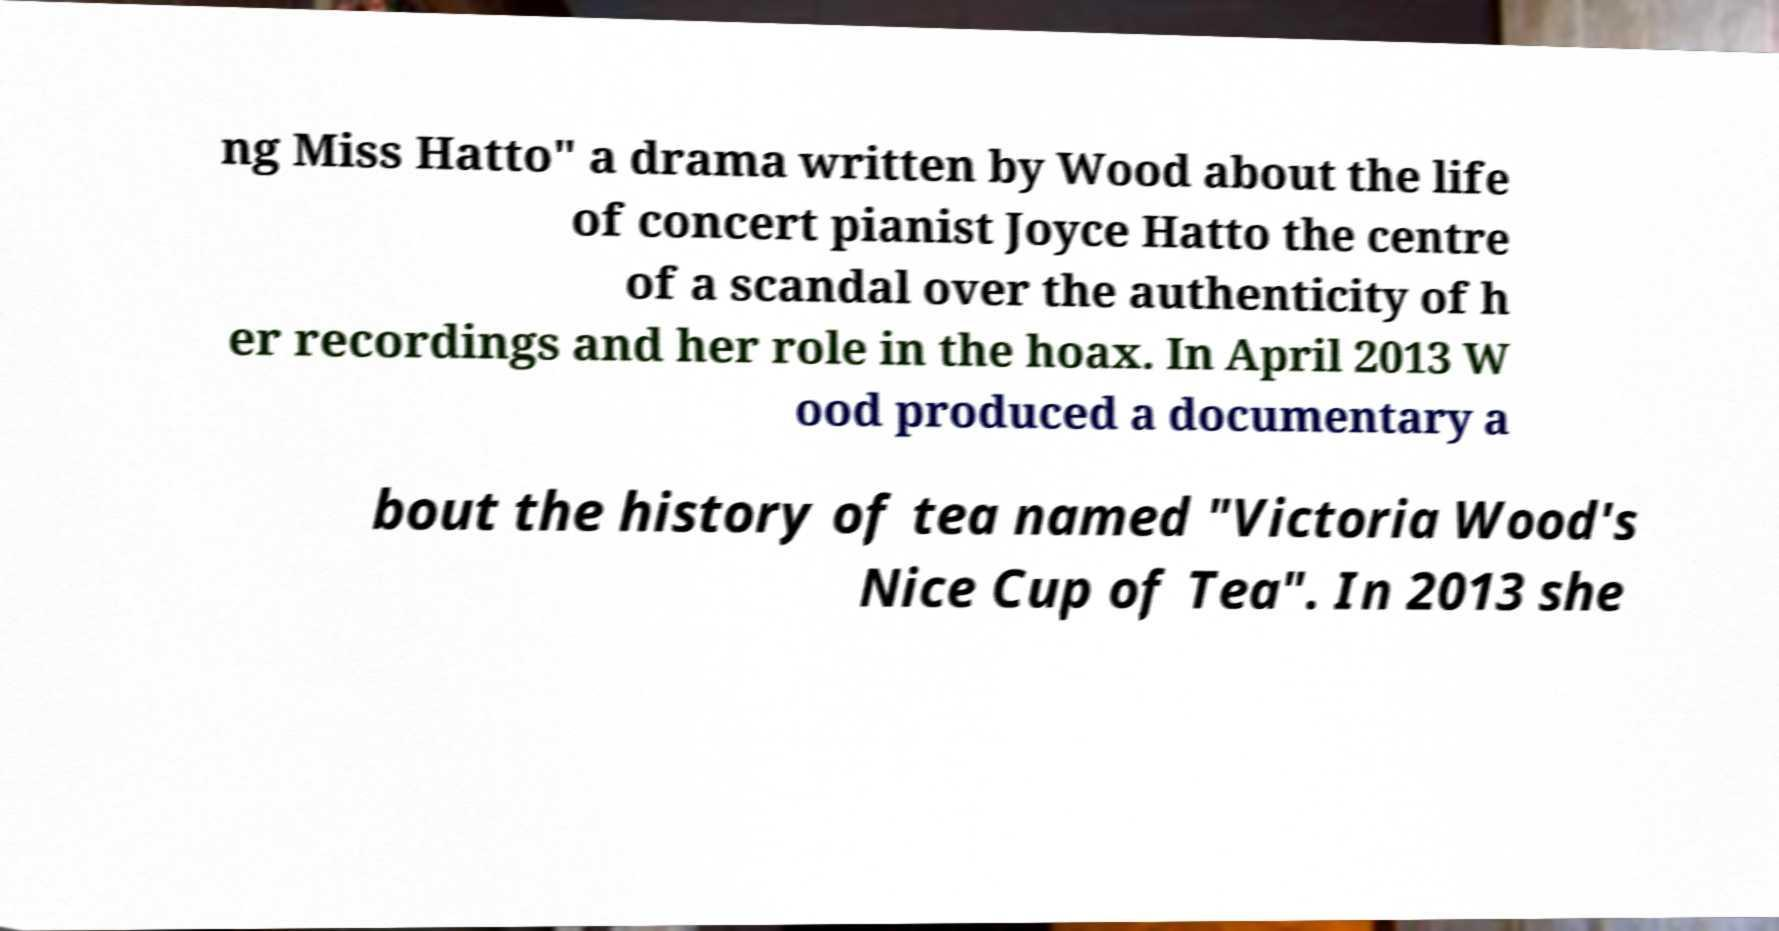Could you extract and type out the text from this image? ng Miss Hatto" a drama written by Wood about the life of concert pianist Joyce Hatto the centre of a scandal over the authenticity of h er recordings and her role in the hoax. In April 2013 W ood produced a documentary a bout the history of tea named "Victoria Wood's Nice Cup of Tea". In 2013 she 